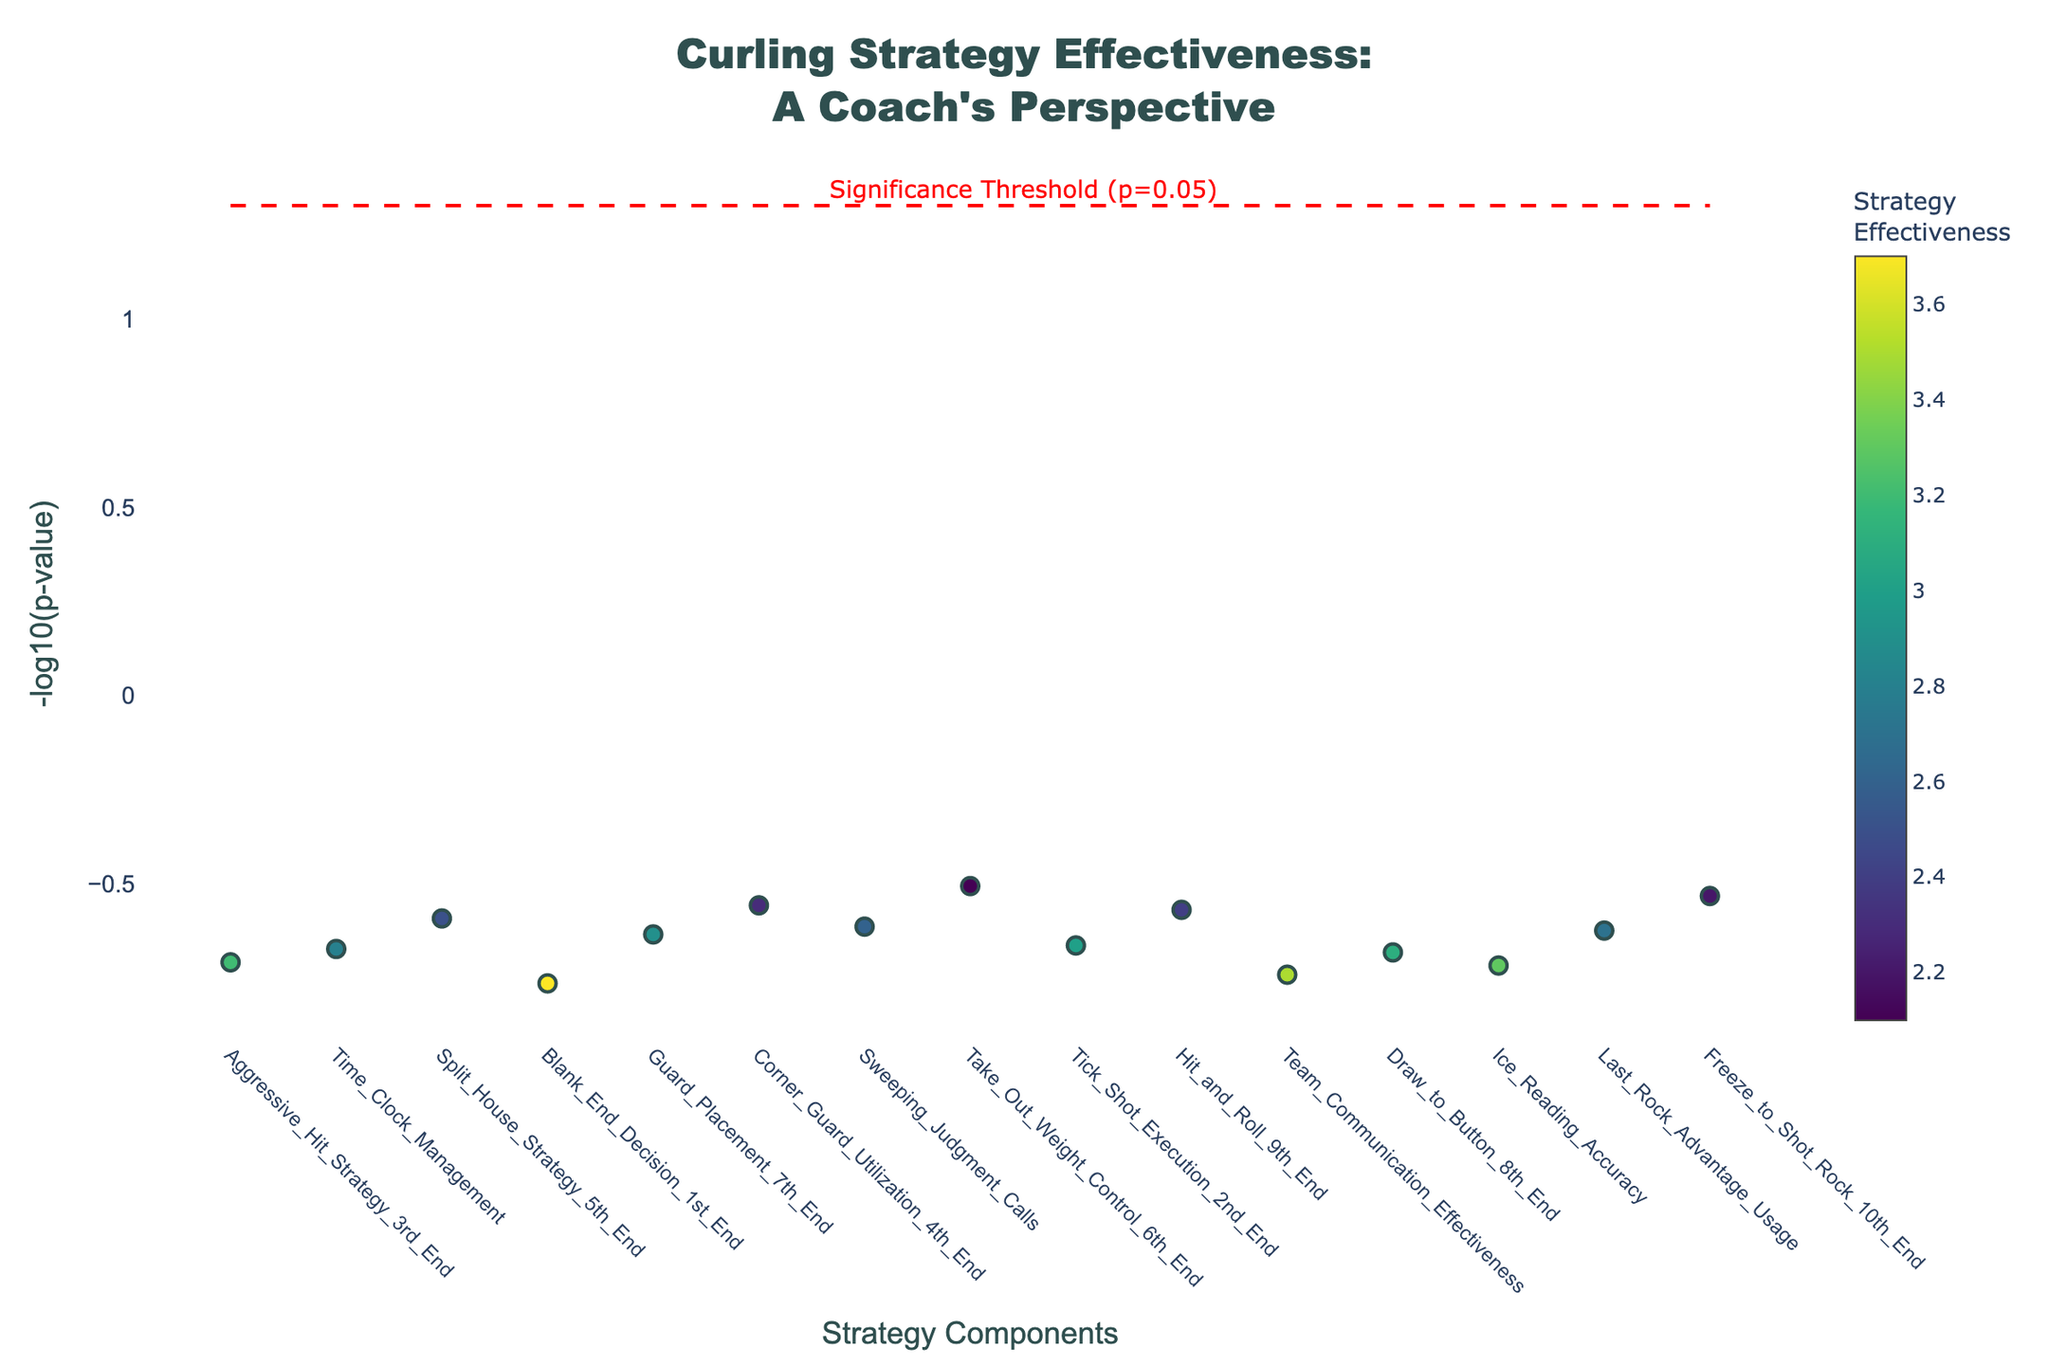What is the title of the plot? The title can be found at the top of the plot, typically in larger and bold font. Here, it reads "Curling Strategy Effectiveness: A Coach's Perspective".
Answer: Curling Strategy Effectiveness: A Coach's Perspective Which strategy appears the most effective based on the -log10(p-value)? Look for the data point with the highest y-value on the plot, corresponding to the highest -log10(p-value). Here, "Freeze_to_Shot_Rock_10th_End" is the highest.
Answer: Freeze_to_Shot_Rock_10th_End What is the significance threshold indicated by the horizontal dashed line? The horizontal dashed line is annotated in red with the label "Significance Threshold (p=0.05)", and its y-value corresponds to -log10(0.05). Calculation: -log10(0.05) ≈ 1.3.
Answer: 1.3 How many strategies have a significance above the threshold? Count the number of data points above the horizontal dashed line at y=1.3. Here, you can identify those points above this threshold visually.
Answer: 15 Which strategy has a "Value" closest to 3.0? Look at the color bar to approximate which data points have a color corresponding to a value near 3.0. Here, "Tick_Shot_Execution_2nd_End" and "Team_Communication_Effectiveness" have values closer to 3.0.
Answer: Tick_Shot_Execution_2nd_End Which two strategies have the closest -log10(p-values)? Compare the -log10(p-values) visually by checking for points that are closely aligned. Here, "Corner_Guard_Utilization_4th_End" and "Sweeping_Judgment_Calls" appear close together.
Answer: Corner_Guard_Utilization_4th_End and Sweeping_Judgment_Calls What strategy falls at the median -log10(p-value) considering all points? Sort the strategies by their -log10(p-values). With 15 points, the median is the 8th value when sorted. Here, "Sweeping_Judgment_Calls" is the median.
Answer: Sweeping_Judgment_Calls Which strategies have a -log10(p-value) less than 4? Identify and count all points below y=4 on the plot. These are the points representing strategies with a -log10(p-value) less than 4.
Answer: Aggressive_Hit_Strategy_3rd_End, Time_Clock_Management, Blank_End_Decision_1st_End, Split_House_Strategy_5th_End, Guard_Placement_7th_End 